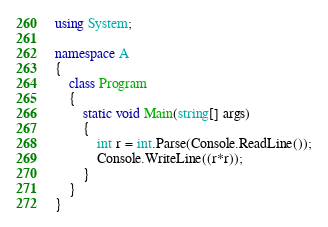Convert code to text. <code><loc_0><loc_0><loc_500><loc_500><_C#_>using System;

namespace A
{
    class Program
    {
        static void Main(string[] args)
        {
            int r = int.Parse(Console.ReadLine());
            Console.WriteLine((r*r));
        }
    }
}
</code> 